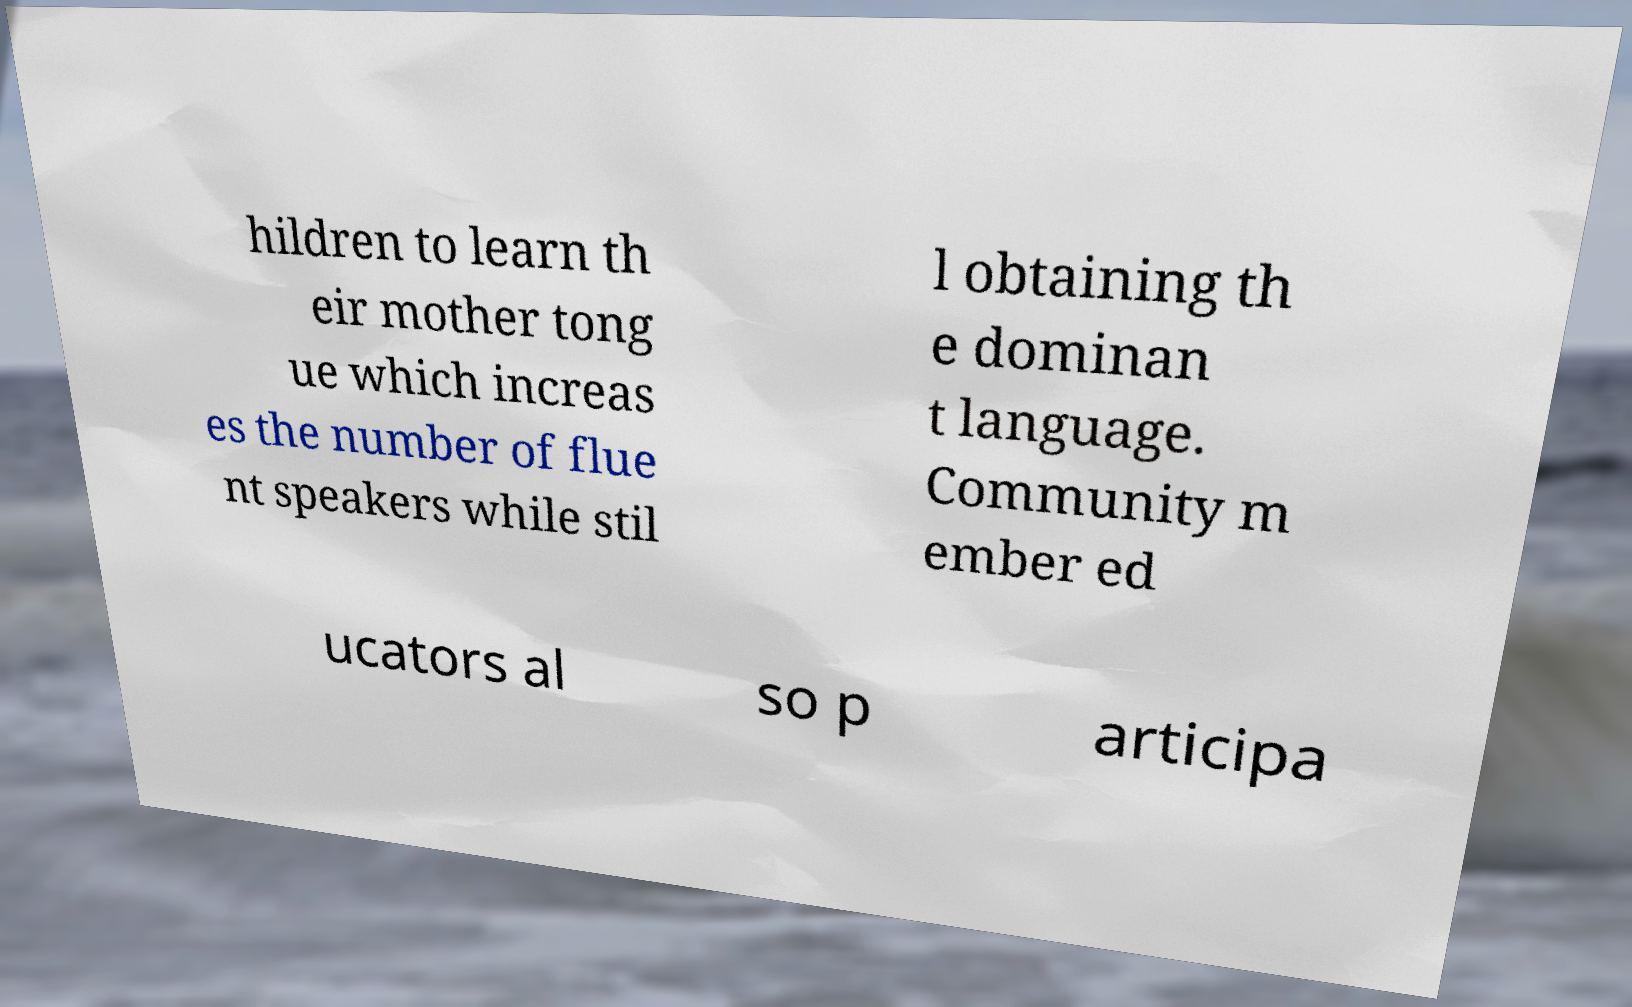Could you extract and type out the text from this image? hildren to learn th eir mother tong ue which increas es the number of flue nt speakers while stil l obtaining th e dominan t language. Community m ember ed ucators al so p articipa 